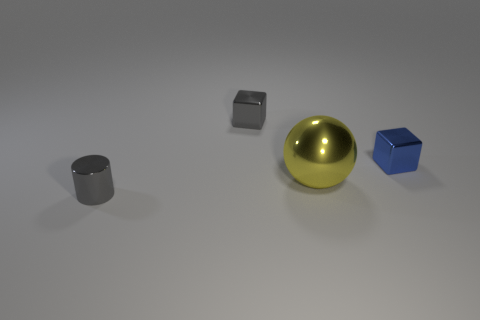Subtract all blue cubes. How many cubes are left? 1 Subtract all purple cubes. How many green spheres are left? 0 Subtract 0 yellow cylinders. How many objects are left? 4 Subtract all balls. How many objects are left? 3 Subtract 1 cylinders. How many cylinders are left? 0 Subtract all brown cubes. Subtract all gray balls. How many cubes are left? 2 Subtract all spheres. Subtract all gray blocks. How many objects are left? 2 Add 4 tiny gray shiny cubes. How many tiny gray shiny cubes are left? 5 Add 4 tiny gray cylinders. How many tiny gray cylinders exist? 5 Add 1 big cyan blocks. How many objects exist? 5 